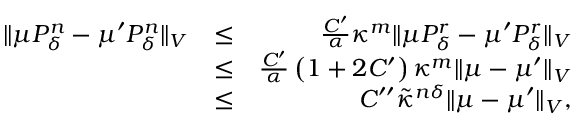<formula> <loc_0><loc_0><loc_500><loc_500>\begin{array} { r l r } { \| \mu P _ { \delta } ^ { n } - \mu ^ { \prime } P _ { \delta } ^ { n } \| _ { V } } & { \leq } & { \frac { C ^ { \prime } } { \alpha } \kappa ^ { m } \| \mu P _ { \delta } ^ { r } - \mu ^ { \prime } P _ { \delta } ^ { r } \| _ { V } } \\ & { \leq } & { \frac { C ^ { \prime } } { \alpha } \left ( 1 + 2 C ^ { \prime } \right ) \kappa ^ { m } \| \mu - \mu ^ { \prime } \| _ { V } } \\ & { \leq } & { C ^ { \prime \prime } \tilde { \kappa } ^ { n \delta } \| \mu - \mu ^ { \prime } \| _ { V } , } \end{array}</formula> 